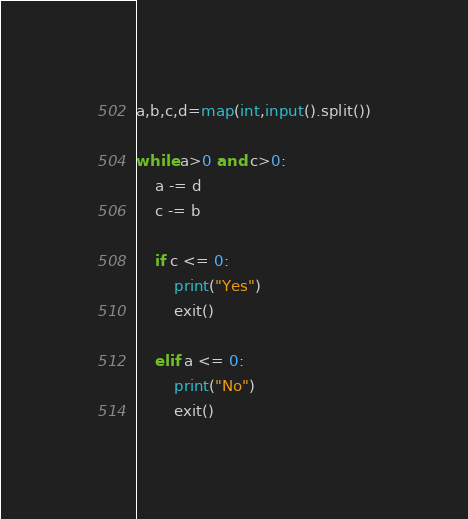Convert code to text. <code><loc_0><loc_0><loc_500><loc_500><_Python_>a,b,c,d=map(int,input().split())

while a>0 and c>0:
    a -= d
    c -= b

    if c <= 0:
        print("Yes")
        exit()

    elif a <= 0:
        print("No")
        exit()</code> 